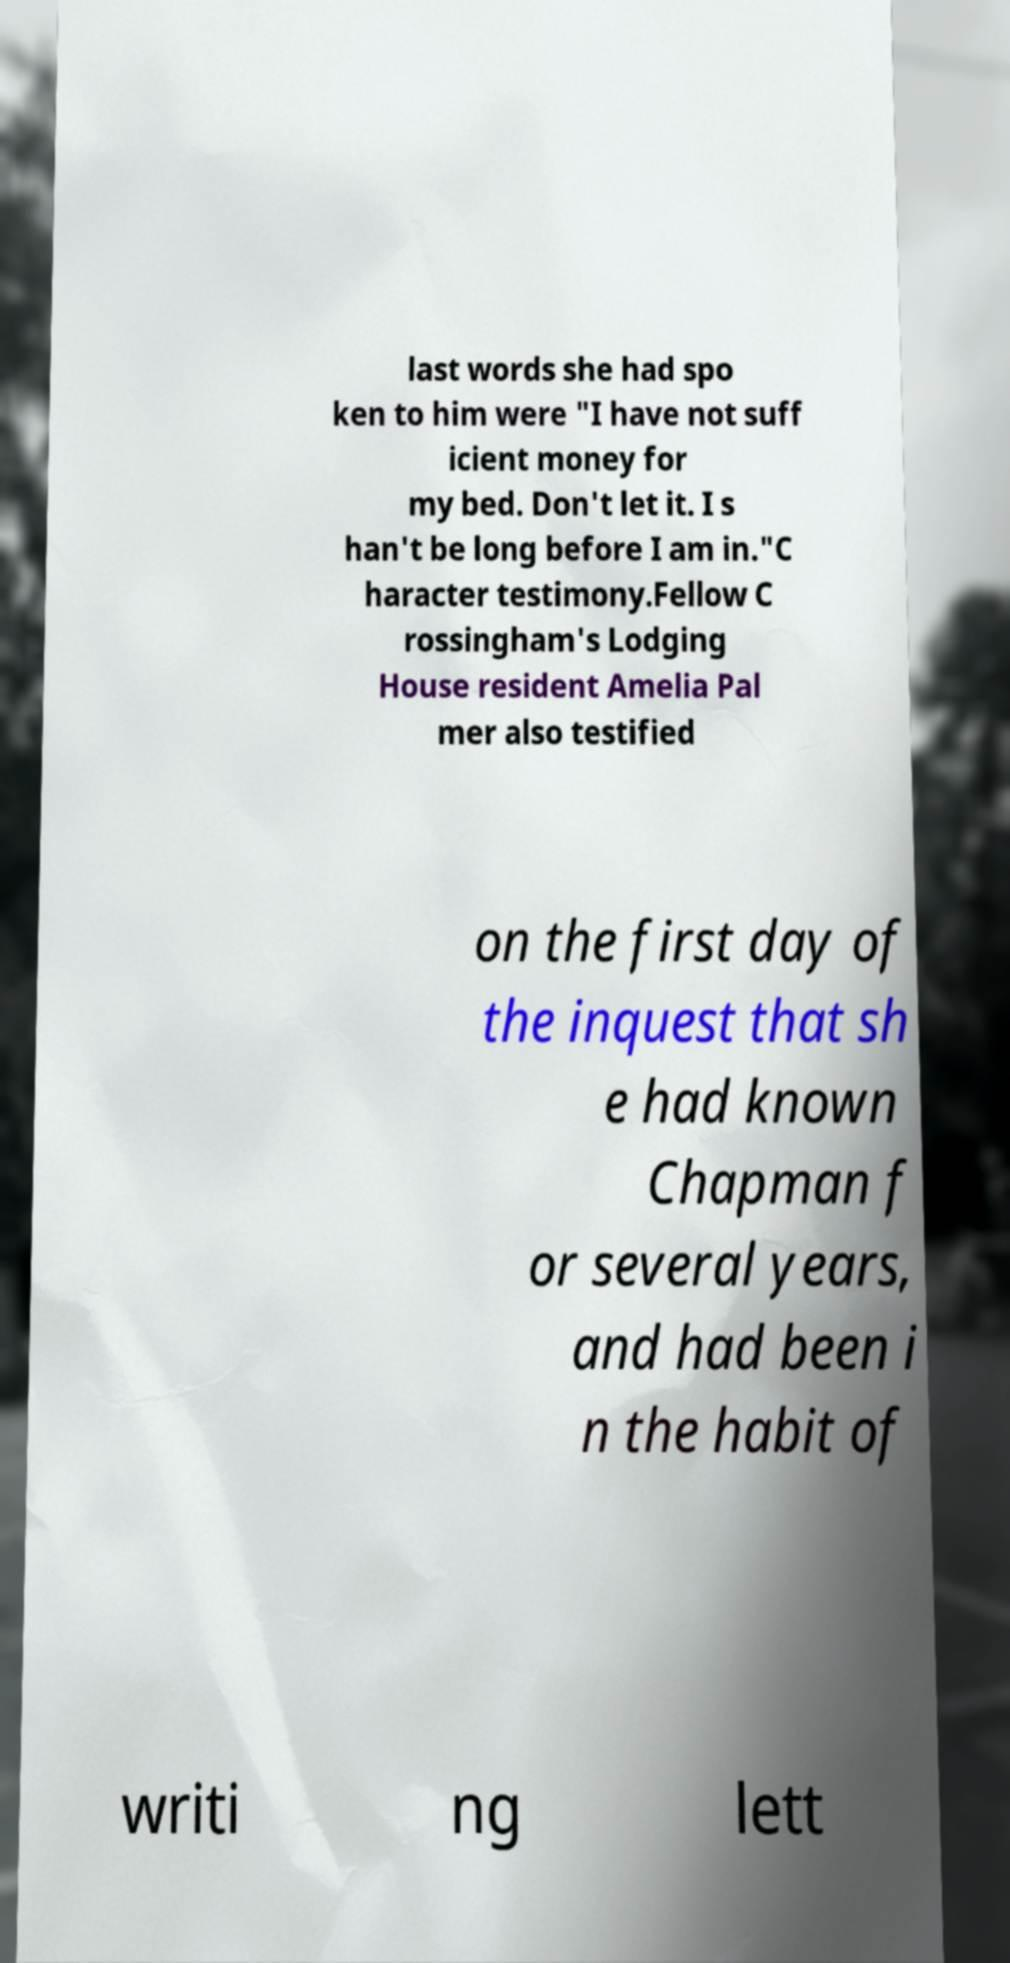What messages or text are displayed in this image? I need them in a readable, typed format. last words she had spo ken to him were "I have not suff icient money for my bed. Don't let it. I s han't be long before I am in."C haracter testimony.Fellow C rossingham's Lodging House resident Amelia Pal mer also testified on the first day of the inquest that sh e had known Chapman f or several years, and had been i n the habit of writi ng lett 